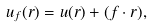Convert formula to latex. <formula><loc_0><loc_0><loc_500><loc_500>u _ { f } ( { r } ) = u ( r ) + ( { f } \cdot { r } ) ,</formula> 